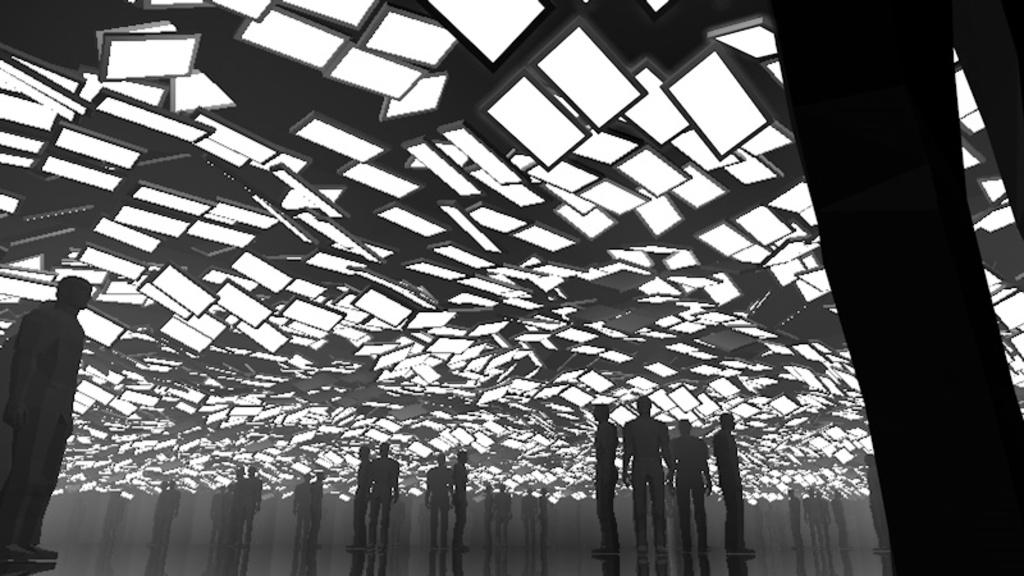What type of image is being described? The image is animated and black and white. What can be seen in the image? There are people standing in the image. Where are the people standing? The people are standing on the floor. What else is visible in the image? There are lights visible at the top of the image. How many chairs are present in the image? There is no mention of chairs in the provided facts, so we cannot determine the number of chairs in the image. 